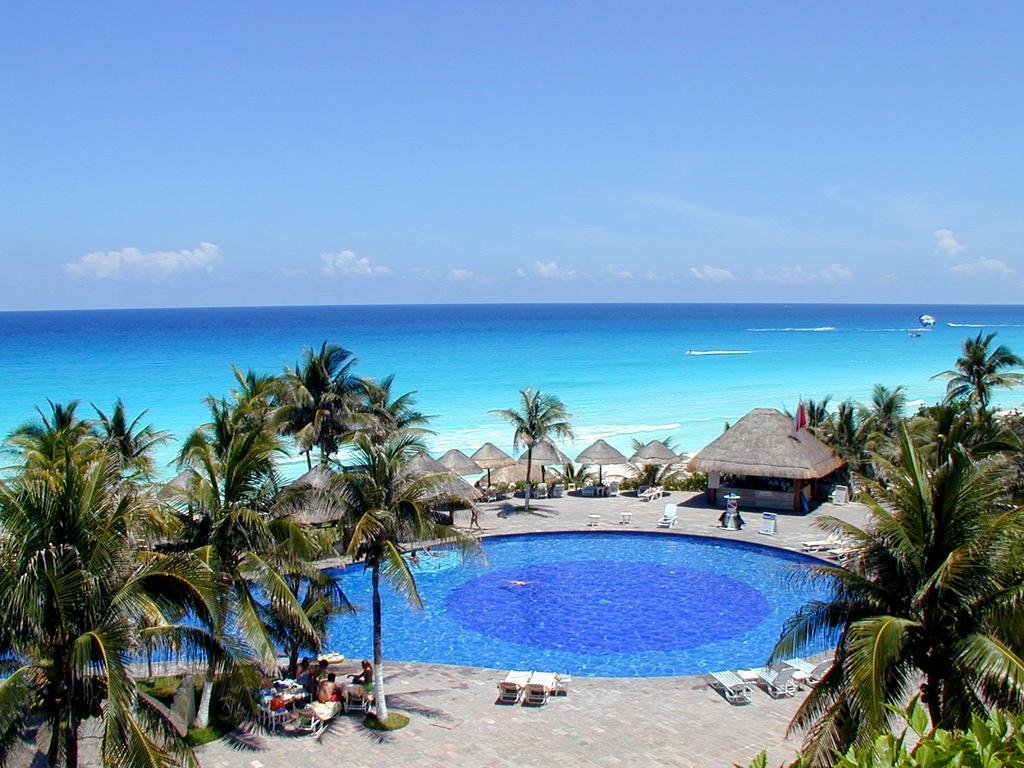In one or two sentences, can you explain what this image depicts? In this image on the right side and left side there are some trees and in the center there is one swimming pool, and also there are some houses and umbrellas. At the bottom there are some people who are sitting on chairs, and also there are some chairs and a floor. In the background there is a beach, and at the top of the image there is sky. 